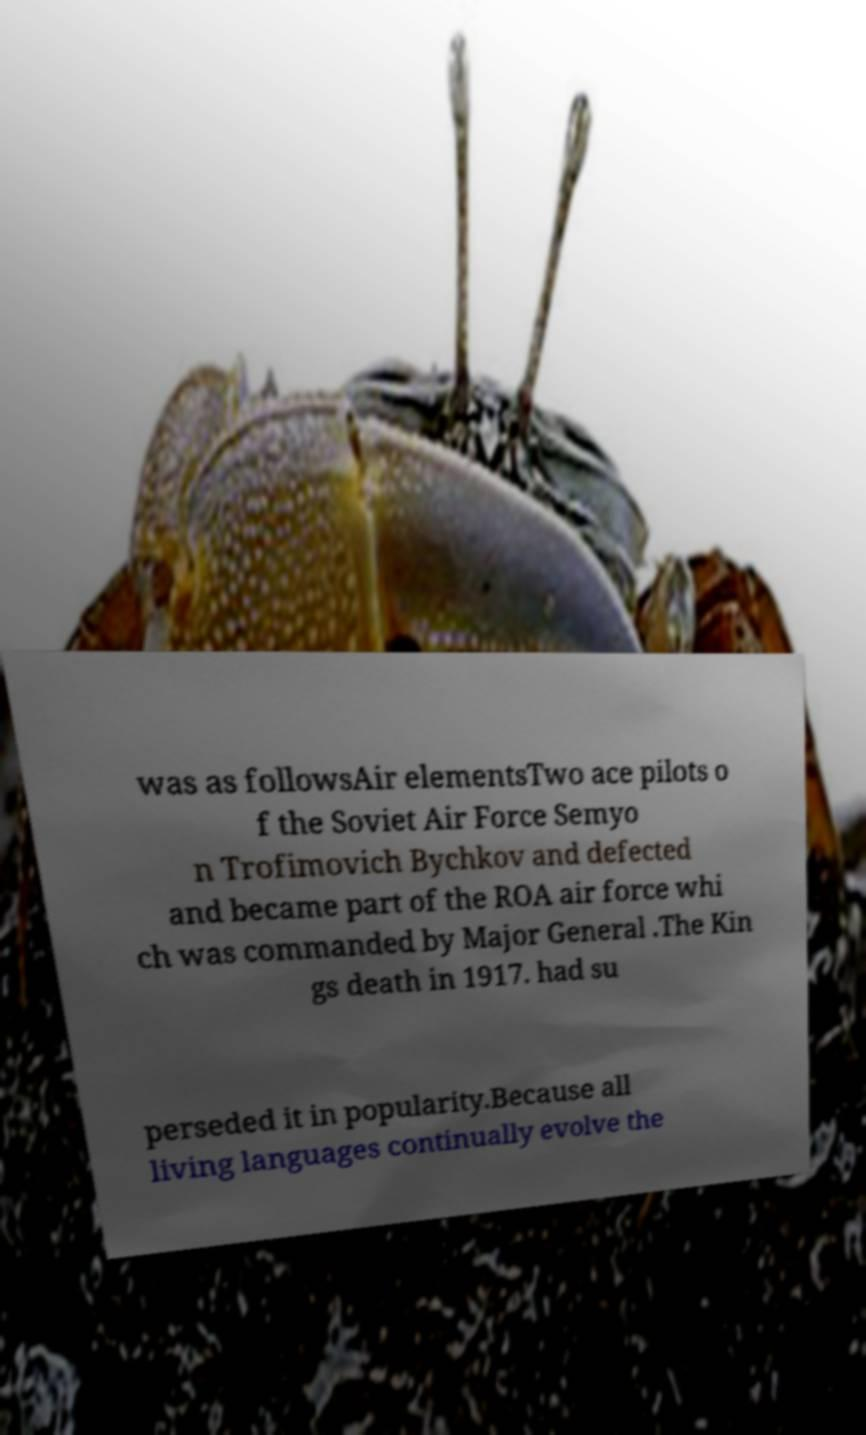Please read and relay the text visible in this image. What does it say? was as followsAir elementsTwo ace pilots o f the Soviet Air Force Semyo n Trofimovich Bychkov and defected and became part of the ROA air force whi ch was commanded by Major General .The Kin gs death in 1917. had su perseded it in popularity.Because all living languages continually evolve the 